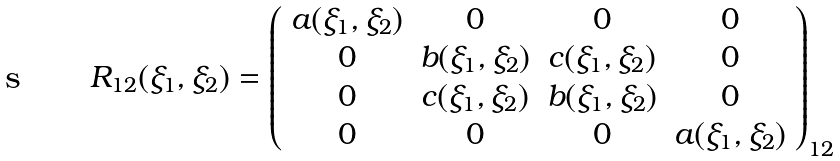Convert formula to latex. <formula><loc_0><loc_0><loc_500><loc_500>R _ { 1 2 } ( \xi _ { 1 } , \xi _ { 2 } ) = \left ( \begin{array} { c c c c } a ( \xi _ { 1 } , \xi _ { 2 } ) & 0 & 0 & 0 \\ 0 & b ( \xi _ { 1 } , \xi _ { 2 } ) & c ( \xi _ { 1 } , \xi _ { 2 } ) & 0 \\ 0 & c ( \xi _ { 1 } , \xi _ { 2 } ) & b ( \xi _ { 1 } , \xi _ { 2 } ) & 0 \\ 0 & 0 & 0 & a ( \xi _ { 1 } , \xi _ { 2 } ) \end{array} \right ) _ { 1 2 }</formula> 